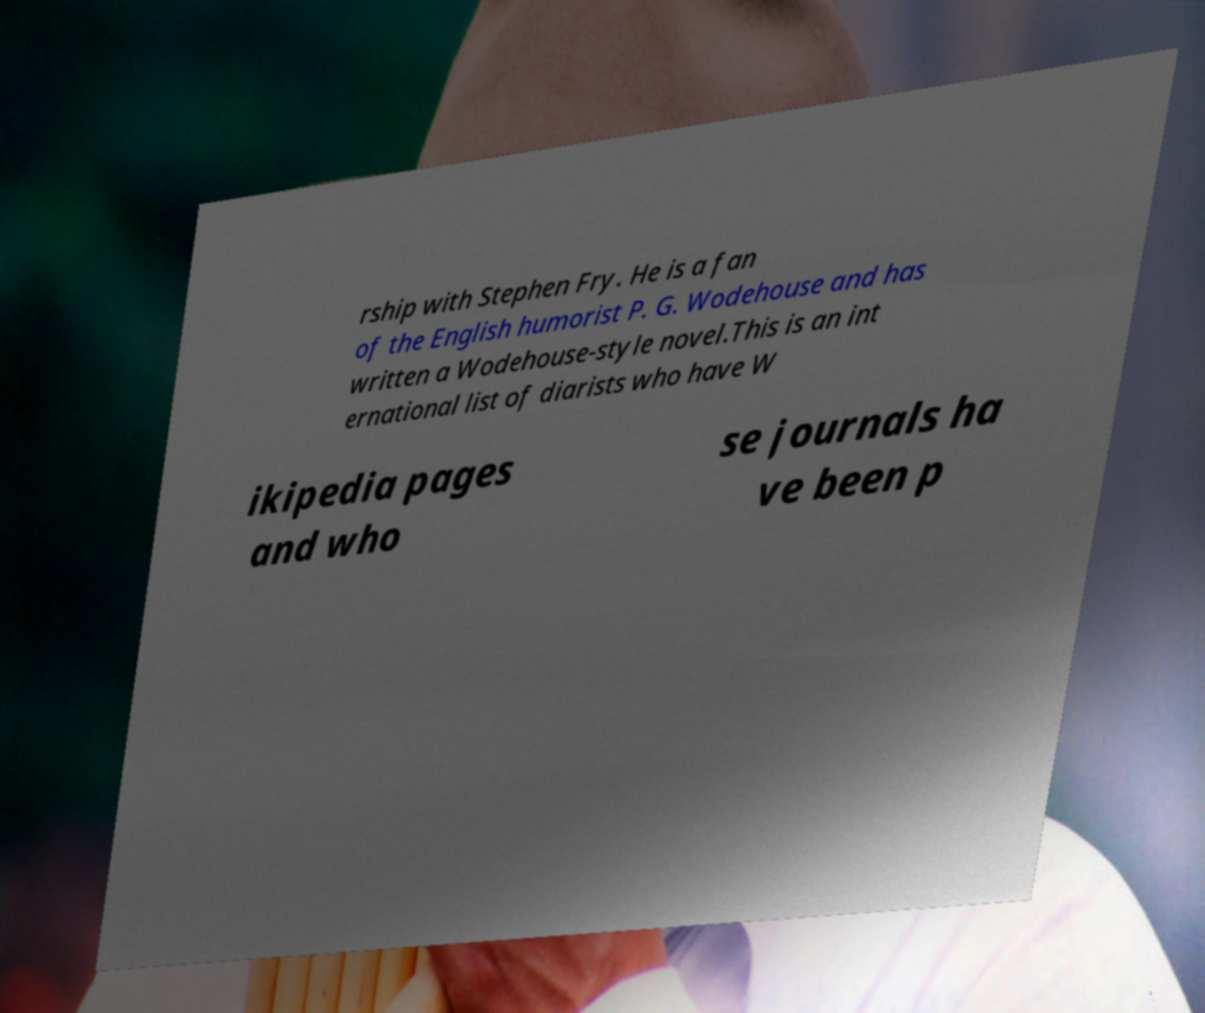Could you extract and type out the text from this image? rship with Stephen Fry. He is a fan of the English humorist P. G. Wodehouse and has written a Wodehouse-style novel.This is an int ernational list of diarists who have W ikipedia pages and who se journals ha ve been p 